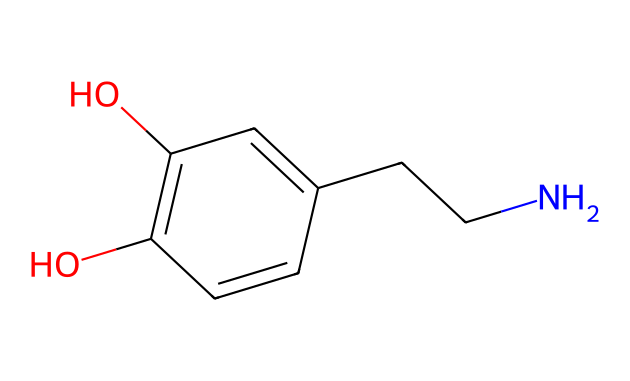What is the molecular formula of this compound? To determine the molecular formula, we need to count the number of each type of atom in the structure. The structure shows 8 carbon (C) atoms, 11 hydrogen (H) atoms, 1 nitrogen (N) atom, and 2 oxygen (O) atoms. Thus, the molecular formula is composed of these elements in their respective counts.
Answer: C8H11NO2 How many hydroxyl (–OH) groups are present in this structure? Looking at the chemical structure, we can identify functional groups. The structure contains two hydroxyl (–OH) groups, indicated by the two oxygen atoms that are bonded to hydrogen atoms.
Answer: 2 What type of nitrogen is present in the structure? The nitrogen atom in this compound is connected to two carbon atoms; thus, it is classified as a secondary amine. This classification is based on the number of carbon-containing groups attached to the nitrogen.
Answer: secondary amine Is this compound aromatic? The presence of a benzene-like ring in the structure, characterized by alternating double bonds and a cyclical arrangement of carbon atoms, indicates that this compound is indeed aromatic. The ring structure fulfills Huckel's rule (4n+2 π electrons) with 6 π electrons.
Answer: Yes How many double bonds does this structure have? By examining the chemical structure, we can identify that there are three double bonds present in the structure: one in the ring and two in the side chain attached to the nitrogen.
Answer: 3 What is the functional group associated with dopamine? The structure reveals that dopamine contains both an amine group (due to the nitrogen) and hydroxyl groups (–OH), which characterize its functional profile. The presence of these groups indicates its role as a neurotransmitter.
Answer: amine and hydroxyl groups 